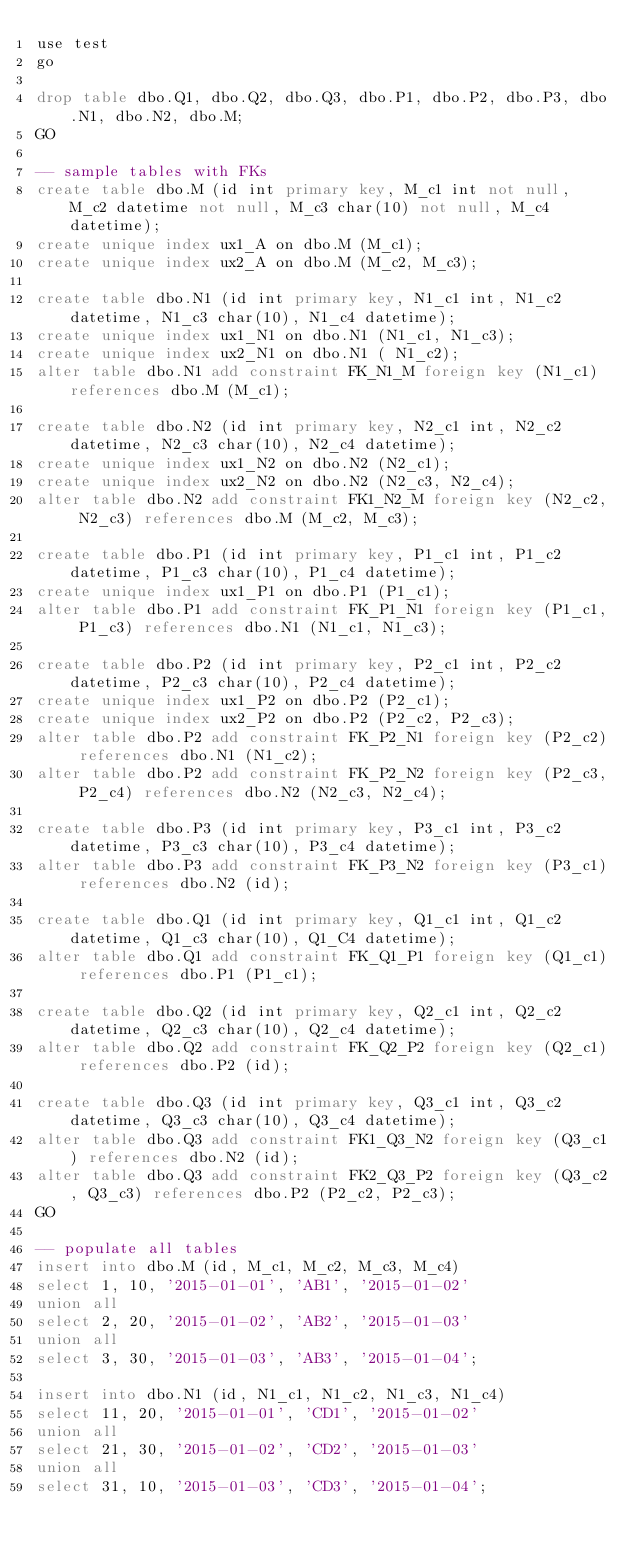<code> <loc_0><loc_0><loc_500><loc_500><_SQL_>use test
go

drop table dbo.Q1, dbo.Q2, dbo.Q3, dbo.P1, dbo.P2, dbo.P3, dbo.N1, dbo.N2, dbo.M;
GO

-- sample tables with FKs
create table dbo.M (id int primary key, M_c1 int not null, M_c2 datetime not null, M_c3 char(10) not null, M_c4 datetime);
create unique index ux1_A on dbo.M (M_c1);
create unique index ux2_A on dbo.M (M_c2, M_c3);

create table dbo.N1 (id int primary key, N1_c1 int, N1_c2 datetime, N1_c3 char(10), N1_c4 datetime);
create unique index ux1_N1 on dbo.N1 (N1_c1, N1_c3);
create unique index ux2_N1 on dbo.N1 ( N1_c2);
alter table dbo.N1 add constraint FK_N1_M foreign key (N1_c1) references dbo.M (M_c1);

create table dbo.N2 (id int primary key, N2_c1 int, N2_c2 datetime, N2_c3 char(10), N2_c4 datetime);
create unique index ux1_N2 on dbo.N2 (N2_c1);
create unique index ux2_N2 on dbo.N2 (N2_c3, N2_c4);
alter table dbo.N2 add constraint FK1_N2_M foreign key (N2_c2, N2_c3) references dbo.M (M_c2, M_c3);

create table dbo.P1 (id int primary key, P1_c1 int, P1_c2 datetime, P1_c3 char(10), P1_c4 datetime);
create unique index ux1_P1 on dbo.P1 (P1_c1);
alter table dbo.P1 add constraint FK_P1_N1 foreign key (P1_c1, P1_c3) references dbo.N1 (N1_c1, N1_c3);

create table dbo.P2 (id int primary key, P2_c1 int, P2_c2 datetime, P2_c3 char(10), P2_c4 datetime);
create unique index ux1_P2 on dbo.P2 (P2_c1);
create unique index ux2_P2 on dbo.P2 (P2_c2, P2_c3);
alter table dbo.P2 add constraint FK_P2_N1 foreign key (P2_c2) references dbo.N1 (N1_c2);
alter table dbo.P2 add constraint FK_P2_N2 foreign key (P2_c3, P2_c4) references dbo.N2 (N2_c3, N2_c4);

create table dbo.P3 (id int primary key, P3_c1 int, P3_c2 datetime, P3_c3 char(10), P3_c4 datetime);
alter table dbo.P3 add constraint FK_P3_N2 foreign key (P3_c1) references dbo.N2 (id);

create table dbo.Q1 (id int primary key, Q1_c1 int, Q1_c2 datetime, Q1_c3 char(10), Q1_C4 datetime);
alter table dbo.Q1 add constraint FK_Q1_P1 foreign key (Q1_c1) references dbo.P1 (P1_c1);

create table dbo.Q2 (id int primary key, Q2_c1 int, Q2_c2 datetime, Q2_c3 char(10), Q2_c4 datetime);
alter table dbo.Q2 add constraint FK_Q2_P2 foreign key (Q2_c1) references dbo.P2 (id);

create table dbo.Q3 (id int primary key, Q3_c1 int, Q3_c2 datetime, Q3_c3 char(10), Q3_c4 datetime);
alter table dbo.Q3 add constraint FK1_Q3_N2 foreign key (Q3_c1) references dbo.N2 (id);
alter table dbo.Q3 add constraint FK2_Q3_P2 foreign key (Q3_c2, Q3_c3) references dbo.P2 (P2_c2, P2_c3);
GO

-- populate all tables
insert into dbo.M (id, M_c1, M_c2, M_c3, M_c4)
select 1, 10, '2015-01-01', 'AB1', '2015-01-02'
union all
select 2, 20, '2015-01-02', 'AB2', '2015-01-03'
union all
select 3, 30, '2015-01-03', 'AB3', '2015-01-04';

insert into dbo.N1 (id, N1_c1, N1_c2, N1_c3, N1_c4)
select 11, 20, '2015-01-01', 'CD1', '2015-01-02'
union all
select 21, 30, '2015-01-02', 'CD2', '2015-01-03'
union all
select 31, 10, '2015-01-03', 'CD3', '2015-01-04';
</code> 